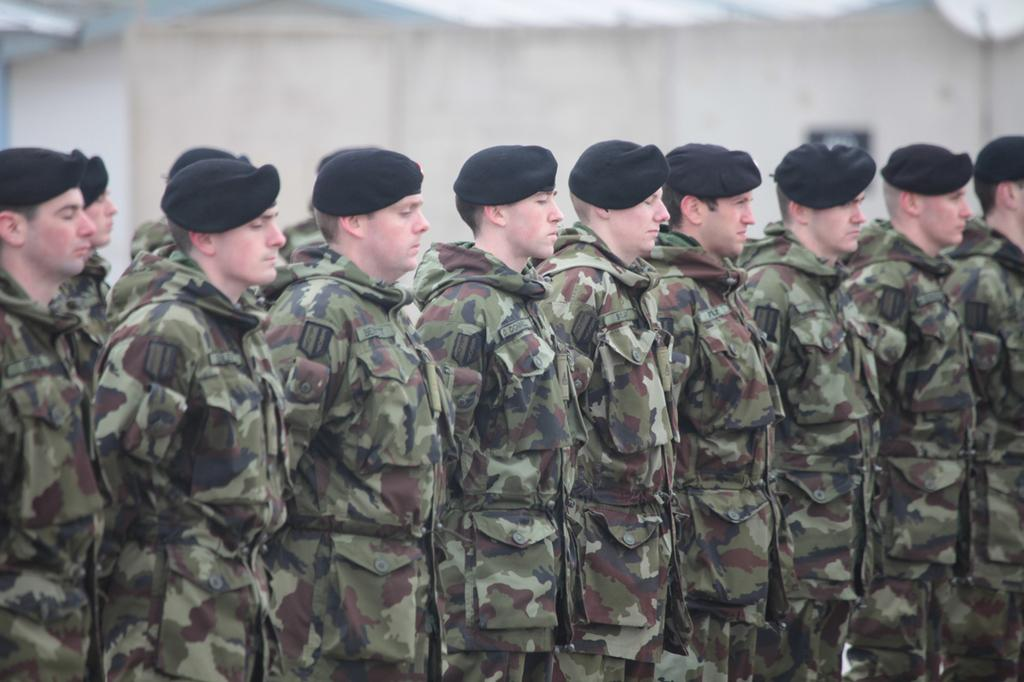What is the main subject of the image? The main subject of the image is a group of people. How are the people in the image positioned? The people are standing in a row. What type of clothing or accessory are the people wearing in the image? The people are wearing caps in the image. What type of brake can be seen in the image? There is no brake present in the image. What book is the person in the middle of the row reading in the image? There is no book or person reading in the image. What type of coil is being used by the people in the image? There is no coil present in the image. 